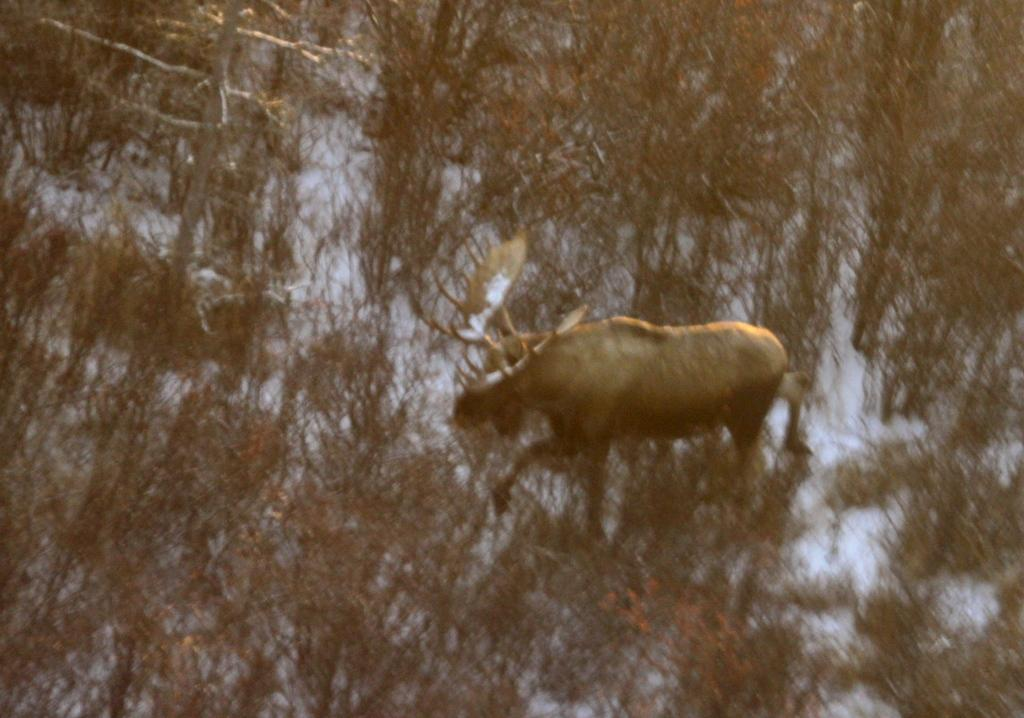What animal can be seen in the image? There is a deer in the image. What is the deer doing in the image? The deer is standing on the ground. What is covering the ground in the image? The ground is covered with snow. What type of vegetation is visible in the image? There are trees in the image. What type of jam is the deer spreading on the toast in the image? There is no toast or jam present in the image; it features a deer standing on snow-covered ground with trees in the background. 